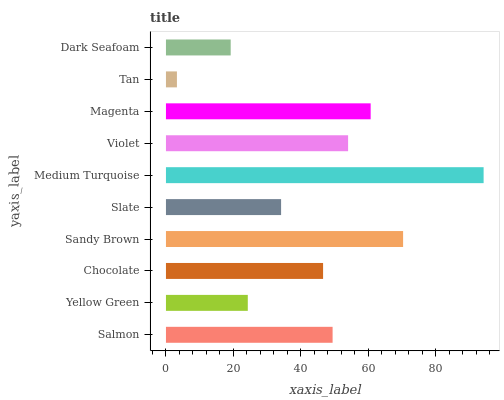Is Tan the minimum?
Answer yes or no. Yes. Is Medium Turquoise the maximum?
Answer yes or no. Yes. Is Yellow Green the minimum?
Answer yes or no. No. Is Yellow Green the maximum?
Answer yes or no. No. Is Salmon greater than Yellow Green?
Answer yes or no. Yes. Is Yellow Green less than Salmon?
Answer yes or no. Yes. Is Yellow Green greater than Salmon?
Answer yes or no. No. Is Salmon less than Yellow Green?
Answer yes or no. No. Is Salmon the high median?
Answer yes or no. Yes. Is Chocolate the low median?
Answer yes or no. Yes. Is Slate the high median?
Answer yes or no. No. Is Violet the low median?
Answer yes or no. No. 